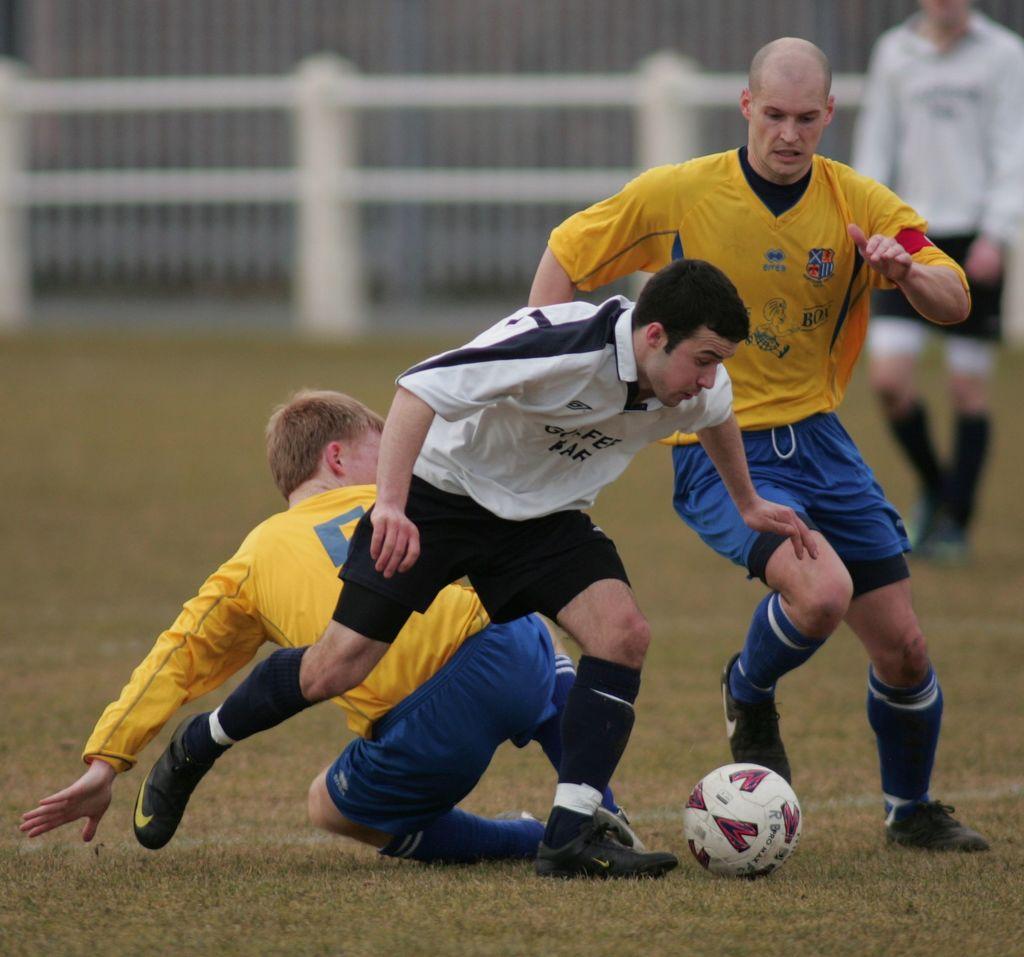Please provide a concise description of this image. In this image we can see a group of people on the ground. We can also see some grass and a ball on the ground. On the backside we can see a fence. 